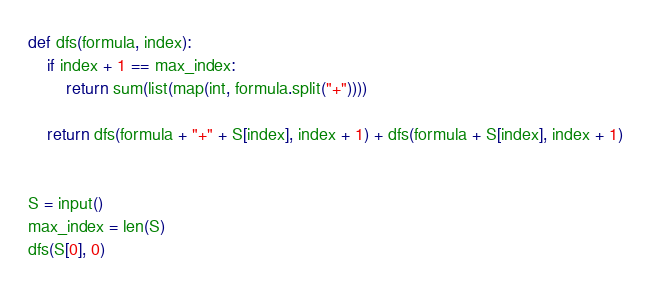<code> <loc_0><loc_0><loc_500><loc_500><_Python_>def dfs(formula, index):
    if index + 1 == max_index:
        return sum(list(map(int, formula.split("+"))))

    return dfs(formula + "+" + S[index], index + 1) + dfs(formula + S[index], index + 1)


S = input()
max_index = len(S)
dfs(S[0], 0)</code> 